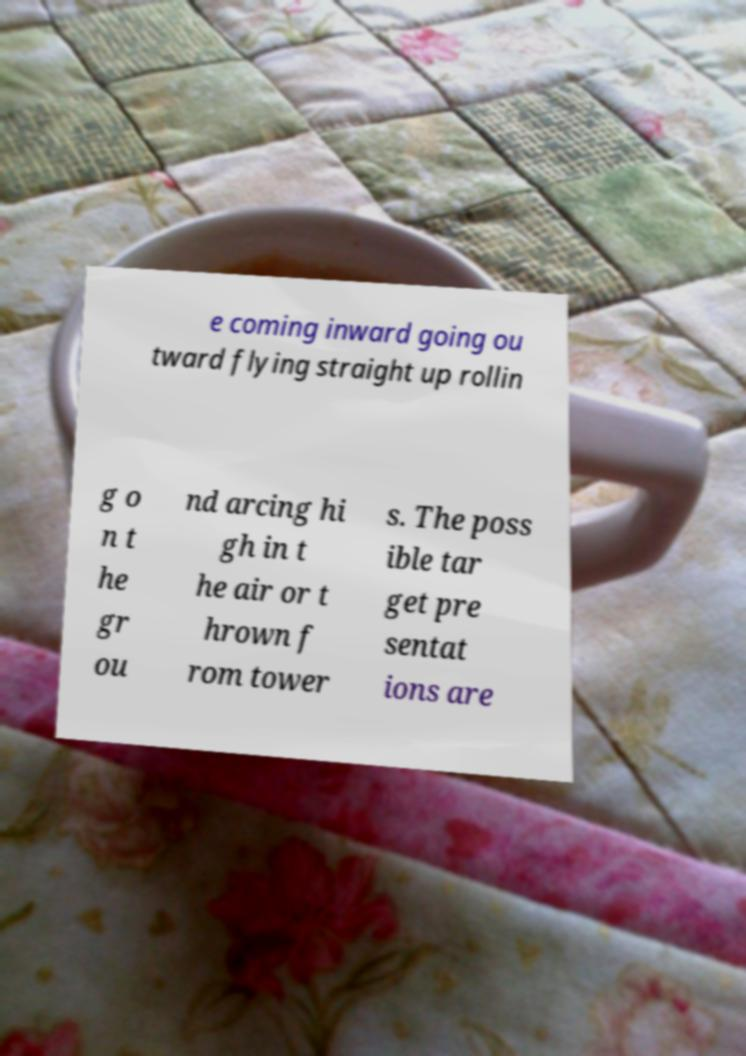There's text embedded in this image that I need extracted. Can you transcribe it verbatim? e coming inward going ou tward flying straight up rollin g o n t he gr ou nd arcing hi gh in t he air or t hrown f rom tower s. The poss ible tar get pre sentat ions are 